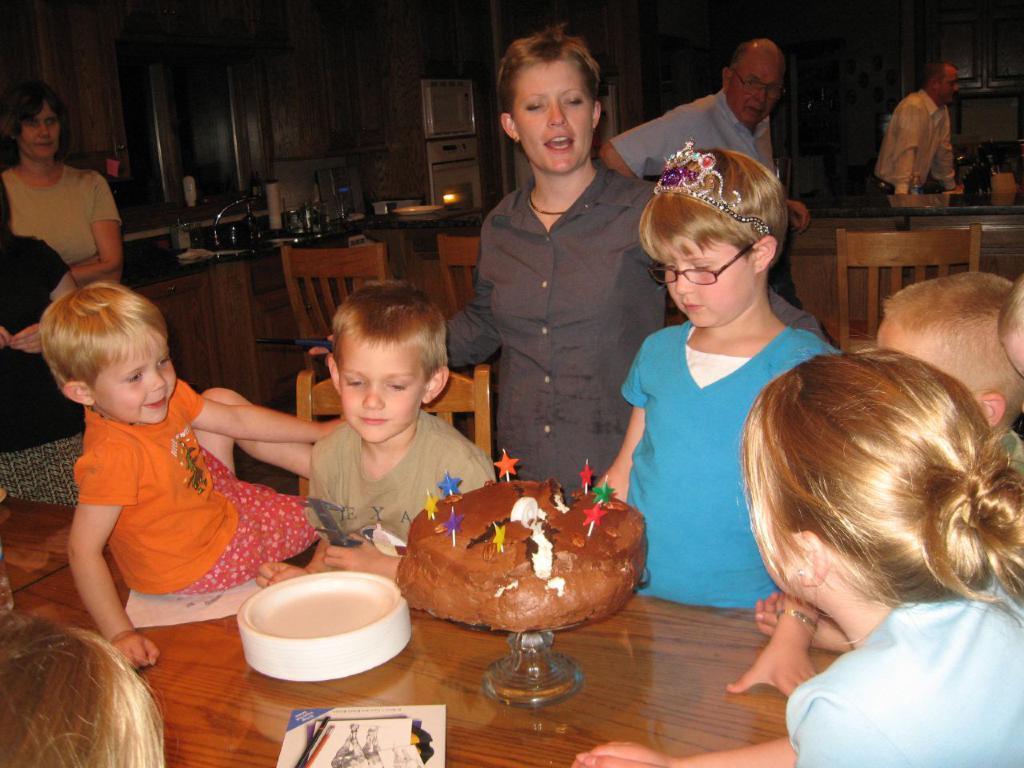In one or two sentences, can you explain what this image depicts? In this image we can see a group of people, cake, table, chairs and other objects. There is a wooden wall in the background. 